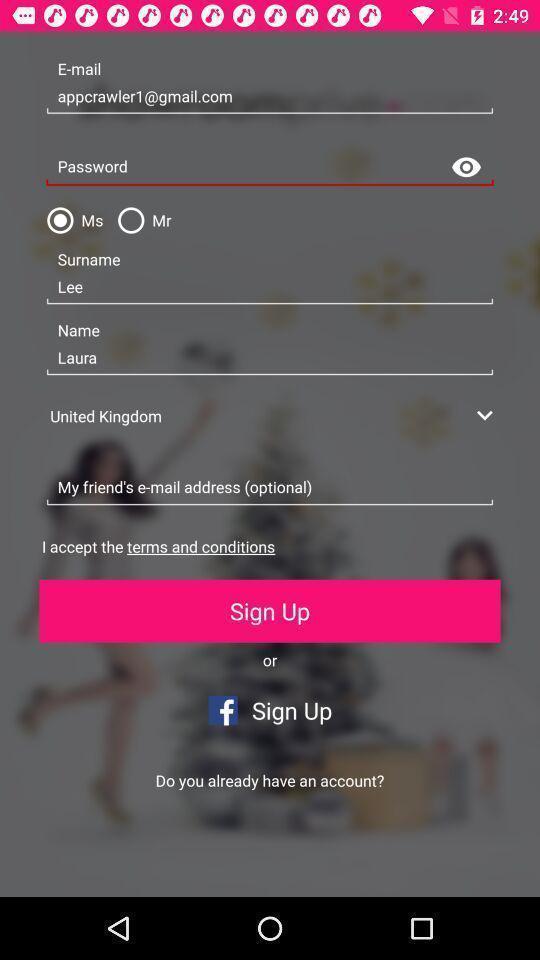Tell me about the visual elements in this screen capture. Sign up page with profile details. 